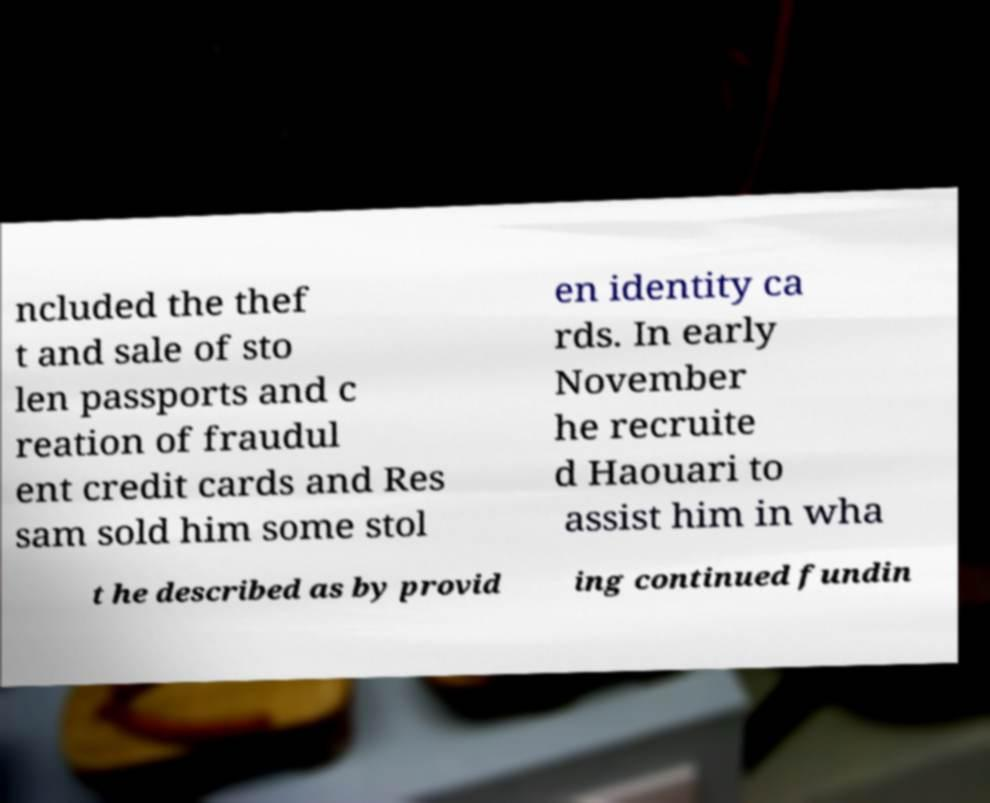I need the written content from this picture converted into text. Can you do that? ncluded the thef t and sale of sto len passports and c reation of fraudul ent credit cards and Res sam sold him some stol en identity ca rds. In early November he recruite d Haouari to assist him in wha t he described as by provid ing continued fundin 